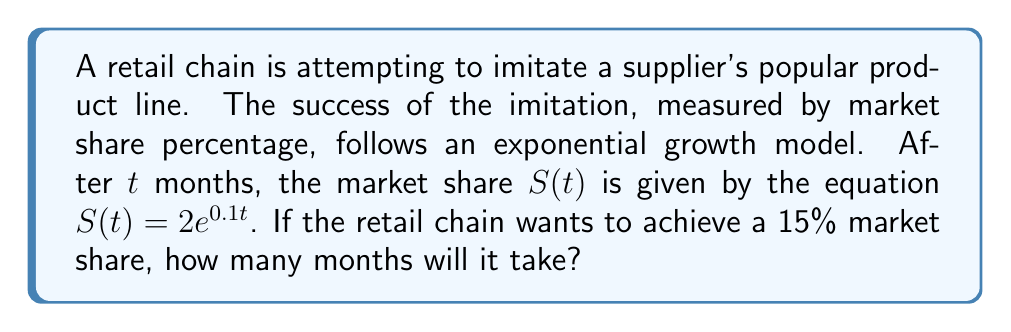Provide a solution to this math problem. To solve this problem, we need to use the given exponential equation and solve for $t$ when $S(t) = 15$. Let's approach this step-by-step:

1) We start with the equation: $S(t) = 2e^{0.1t}$

2) We want to find $t$ when $S(t) = 15$, so we set up the equation:
   $15 = 2e^{0.1t}$

3) Divide both sides by 2:
   $\frac{15}{2} = e^{0.1t}$

4) Take the natural logarithm of both sides:
   $\ln(\frac{15}{2}) = \ln(e^{0.1t})$

5) Using the property of logarithms, $\ln(e^x) = x$, we get:
   $\ln(\frac{15}{2}) = 0.1t$

6) Solve for $t$:
   $t = \frac{\ln(\frac{15}{2})}{0.1}$

7) Calculate the value:
   $t = \frac{\ln(7.5)}{0.1} \approx 20.27$

8) Since we're dealing with months, we round up to the nearest whole number.

Therefore, it will take 21 months for the retail chain to achieve a 15% market share.
Answer: 21 months 